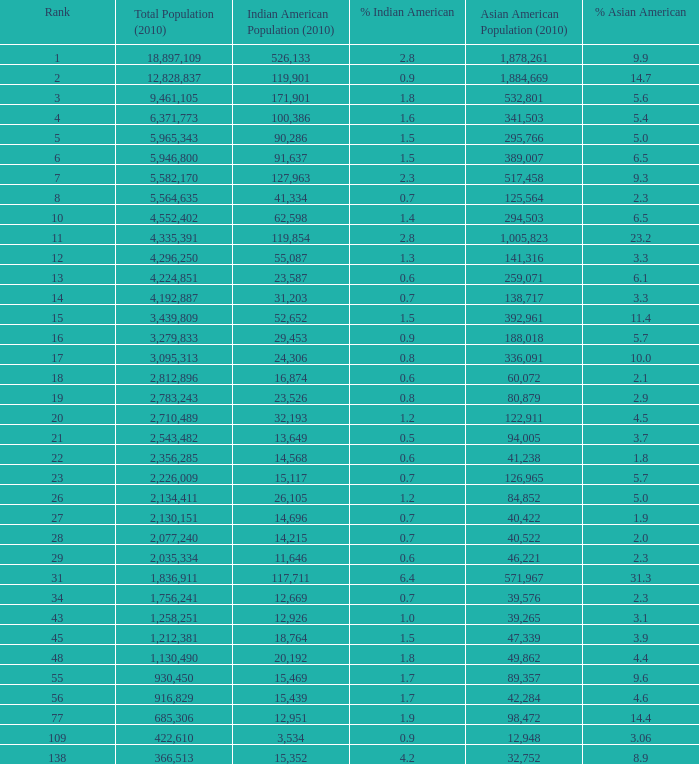What's the total population when there are 5.7% Asian American and fewer than 126,965 Asian American Population? None. 